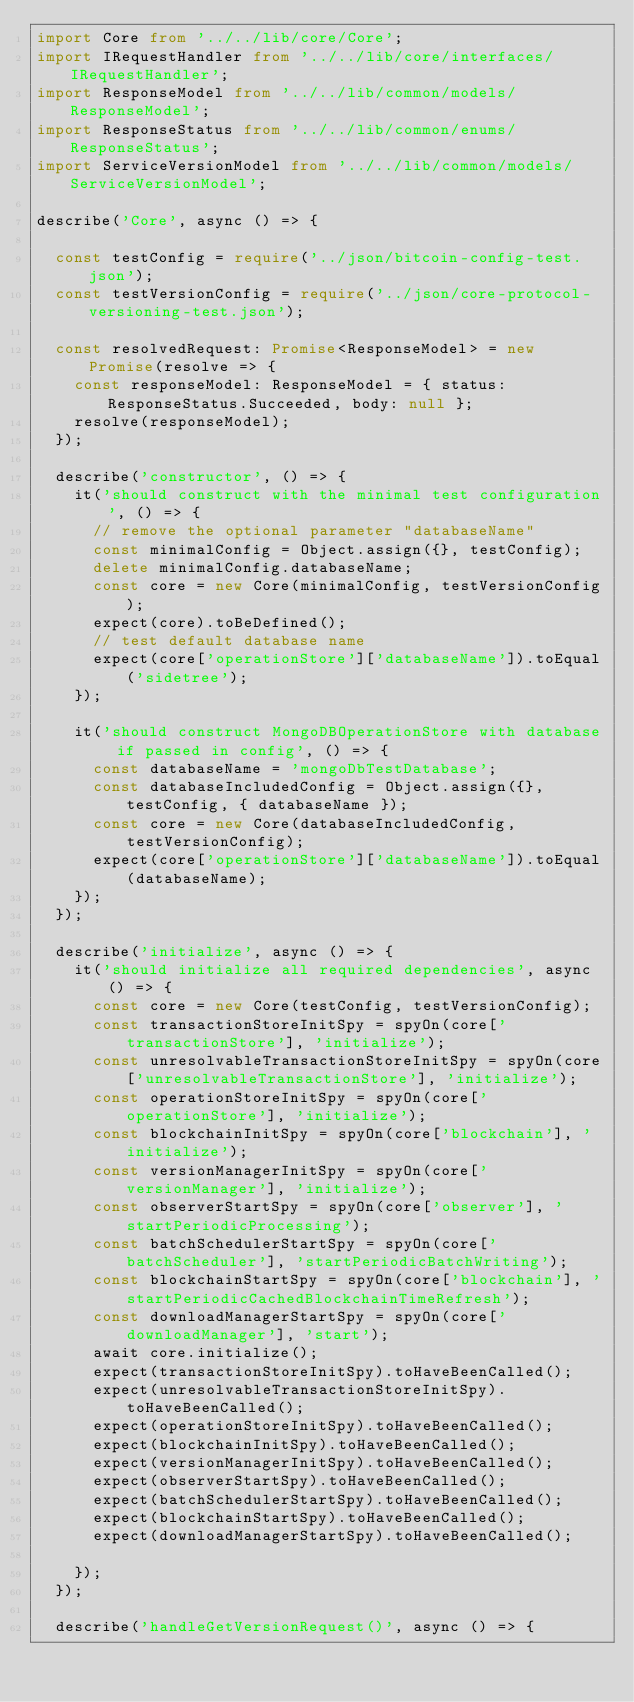<code> <loc_0><loc_0><loc_500><loc_500><_TypeScript_>import Core from '../../lib/core/Core';
import IRequestHandler from '../../lib/core/interfaces/IRequestHandler';
import ResponseModel from '../../lib/common/models/ResponseModel';
import ResponseStatus from '../../lib/common/enums/ResponseStatus';
import ServiceVersionModel from '../../lib/common/models/ServiceVersionModel';

describe('Core', async () => {

  const testConfig = require('../json/bitcoin-config-test.json');
  const testVersionConfig = require('../json/core-protocol-versioning-test.json');

  const resolvedRequest: Promise<ResponseModel> = new Promise(resolve => {
    const responseModel: ResponseModel = { status: ResponseStatus.Succeeded, body: null };
    resolve(responseModel);
  });

  describe('constructor', () => {
    it('should construct with the minimal test configuration', () => {
      // remove the optional parameter "databaseName"
      const minimalConfig = Object.assign({}, testConfig);
      delete minimalConfig.databaseName;
      const core = new Core(minimalConfig, testVersionConfig);
      expect(core).toBeDefined();
      // test default database name
      expect(core['operationStore']['databaseName']).toEqual('sidetree');
    });

    it('should construct MongoDBOperationStore with database if passed in config', () => {
      const databaseName = 'mongoDbTestDatabase';
      const databaseIncludedConfig = Object.assign({}, testConfig, { databaseName });
      const core = new Core(databaseIncludedConfig, testVersionConfig);
      expect(core['operationStore']['databaseName']).toEqual(databaseName);
    });
  });

  describe('initialize', async () => {
    it('should initialize all required dependencies', async () => {
      const core = new Core(testConfig, testVersionConfig);
      const transactionStoreInitSpy = spyOn(core['transactionStore'], 'initialize');
      const unresolvableTransactionStoreInitSpy = spyOn(core['unresolvableTransactionStore'], 'initialize');
      const operationStoreInitSpy = spyOn(core['operationStore'], 'initialize');
      const blockchainInitSpy = spyOn(core['blockchain'], 'initialize');
      const versionManagerInitSpy = spyOn(core['versionManager'], 'initialize');
      const observerStartSpy = spyOn(core['observer'], 'startPeriodicProcessing');
      const batchSchedulerStartSpy = spyOn(core['batchScheduler'], 'startPeriodicBatchWriting');
      const blockchainStartSpy = spyOn(core['blockchain'], 'startPeriodicCachedBlockchainTimeRefresh');
      const downloadManagerStartSpy = spyOn(core['downloadManager'], 'start');
      await core.initialize();
      expect(transactionStoreInitSpy).toHaveBeenCalled();
      expect(unresolvableTransactionStoreInitSpy).toHaveBeenCalled();
      expect(operationStoreInitSpy).toHaveBeenCalled();
      expect(blockchainInitSpy).toHaveBeenCalled();
      expect(versionManagerInitSpy).toHaveBeenCalled();
      expect(observerStartSpy).toHaveBeenCalled();
      expect(batchSchedulerStartSpy).toHaveBeenCalled();
      expect(blockchainStartSpy).toHaveBeenCalled();
      expect(downloadManagerStartSpy).toHaveBeenCalled();

    });
  });

  describe('handleGetVersionRequest()', async () => {</code> 